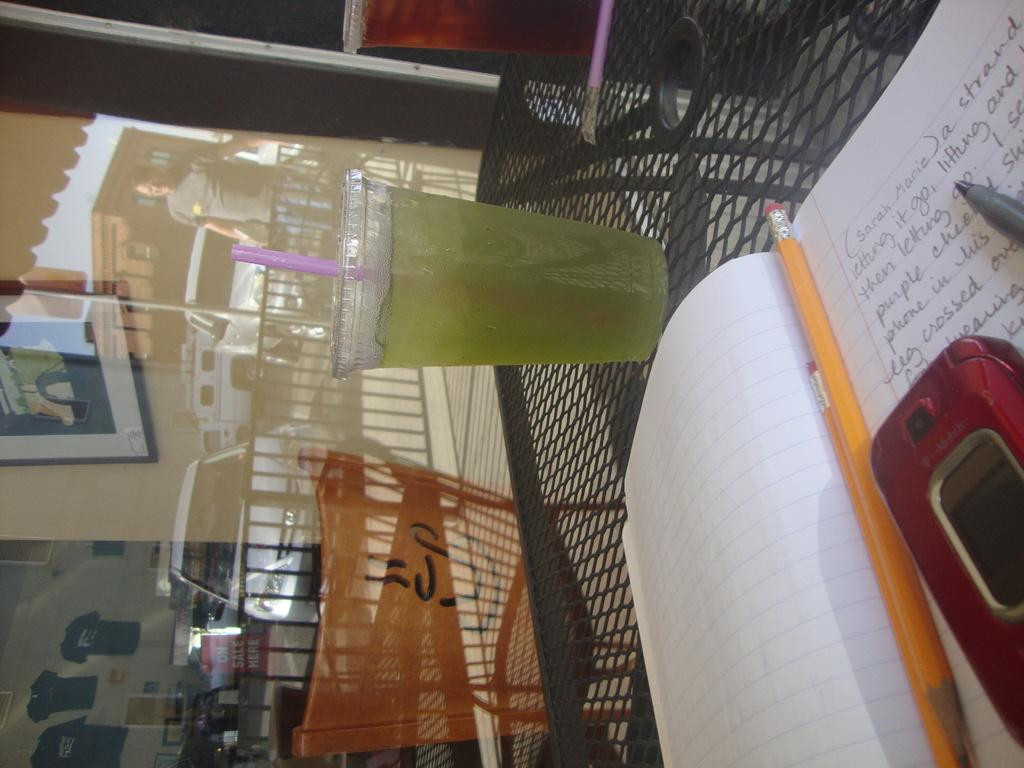Provide a one-sentence caption for the provided image. a notepad sits on the table with the words sarah marie written on it. 